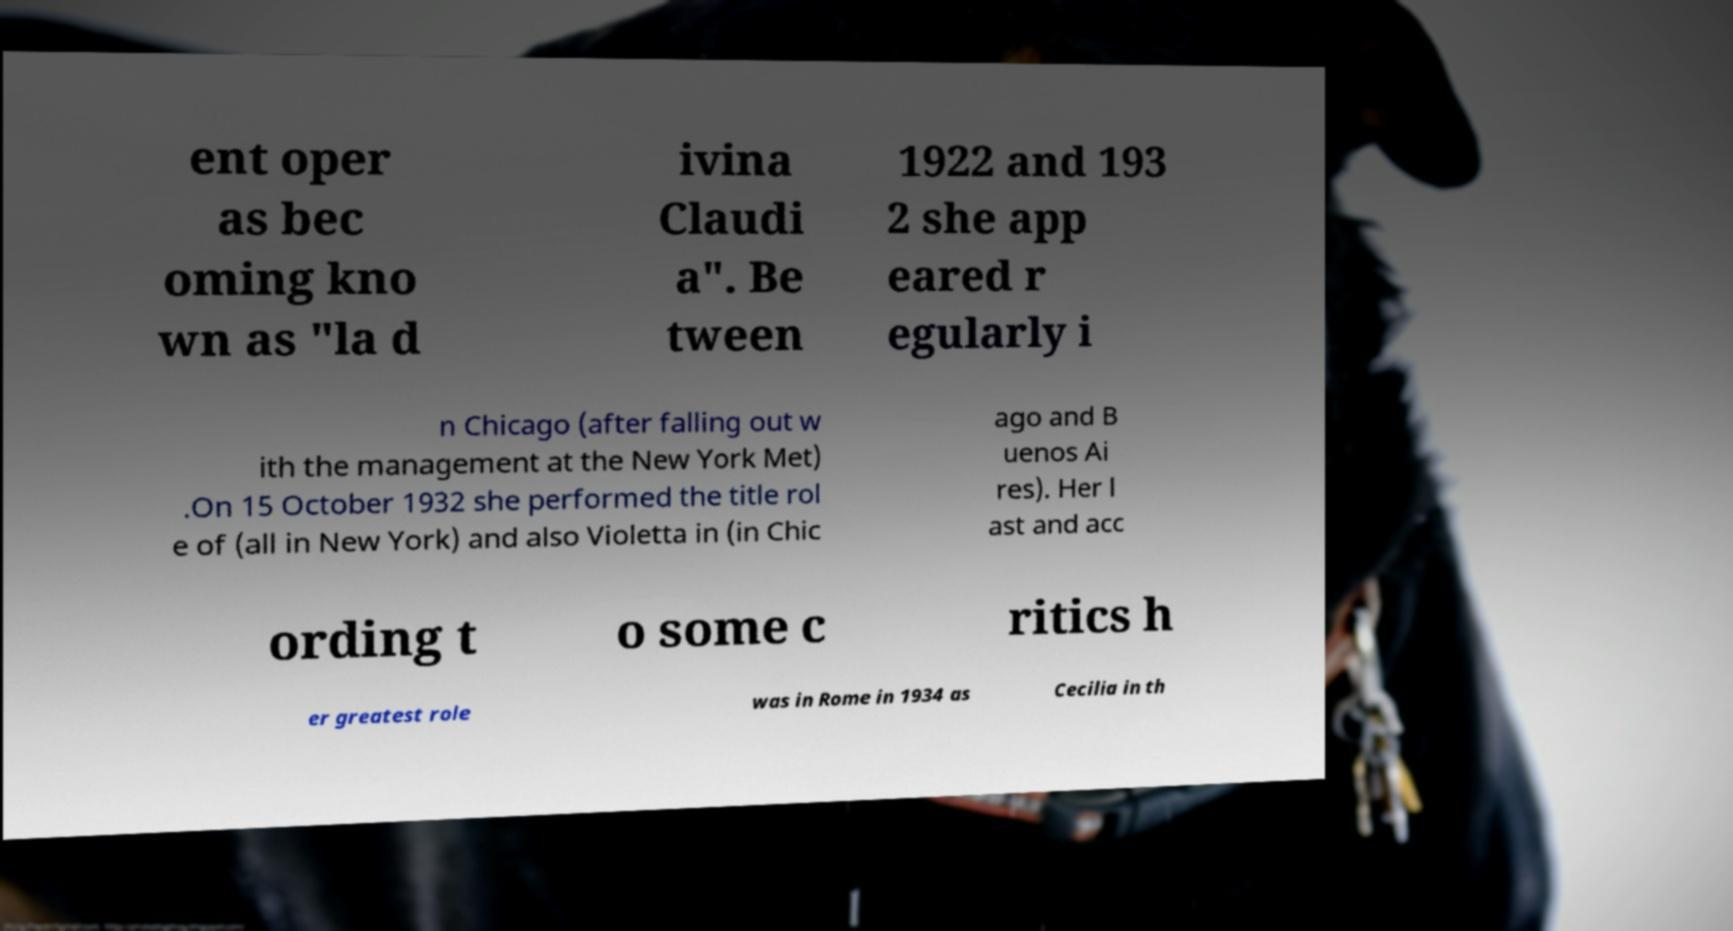Please identify and transcribe the text found in this image. ent oper as bec oming kno wn as "la d ivina Claudi a". Be tween 1922 and 193 2 she app eared r egularly i n Chicago (after falling out w ith the management at the New York Met) .On 15 October 1932 she performed the title rol e of (all in New York) and also Violetta in (in Chic ago and B uenos Ai res). Her l ast and acc ording t o some c ritics h er greatest role was in Rome in 1934 as Cecilia in th 